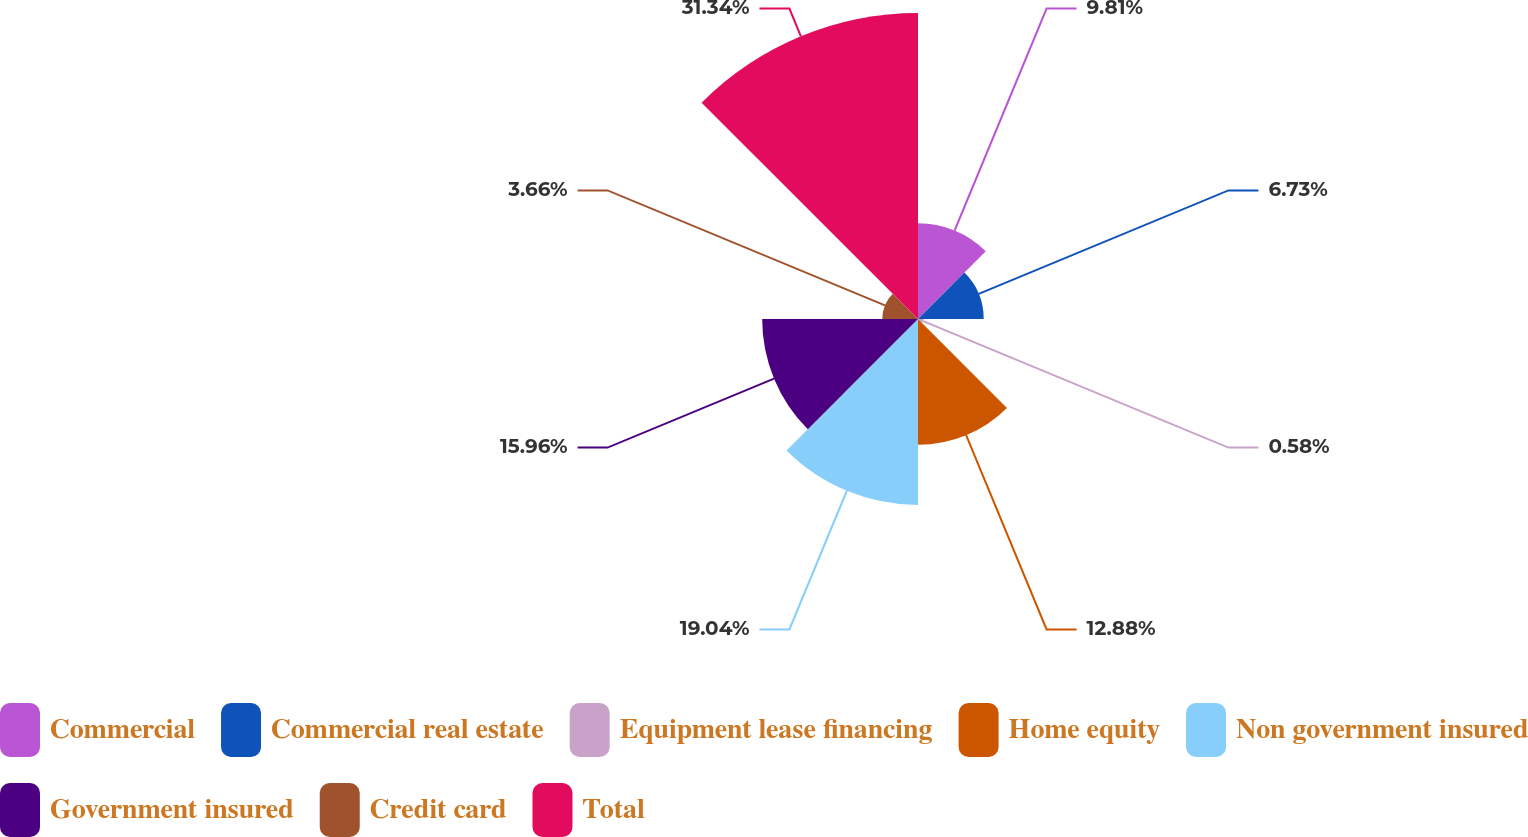Convert chart to OTSL. <chart><loc_0><loc_0><loc_500><loc_500><pie_chart><fcel>Commercial<fcel>Commercial real estate<fcel>Equipment lease financing<fcel>Home equity<fcel>Non government insured<fcel>Government insured<fcel>Credit card<fcel>Total<nl><fcel>9.81%<fcel>6.73%<fcel>0.58%<fcel>12.88%<fcel>19.04%<fcel>15.96%<fcel>3.66%<fcel>31.34%<nl></chart> 